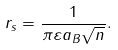Convert formula to latex. <formula><loc_0><loc_0><loc_500><loc_500>r _ { s } = \frac { 1 } { \pi \varepsilon a _ { B } \sqrt { n } } .</formula> 